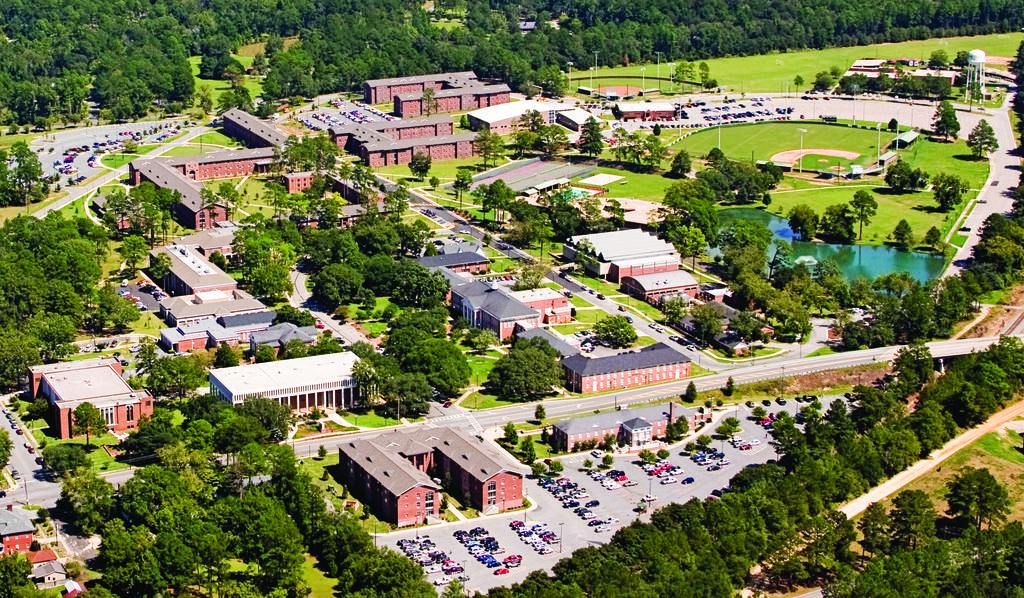What type of view is shown in the image? The image is an aerial view of a city. What type of vegetation can be seen in the image? There are trees and plants visible in the image. What type of structures can be seen in the image? There are houses, buildings, and vehicles visible in the image. What type of ground cover can be seen in the image? There is grass visible in the image. What type of clover can be seen growing in the image? There is no clover visible in the image. What type of bread is being served at the outdoor cafe in the image? There is no outdoor cafe or bread visible in the image. 